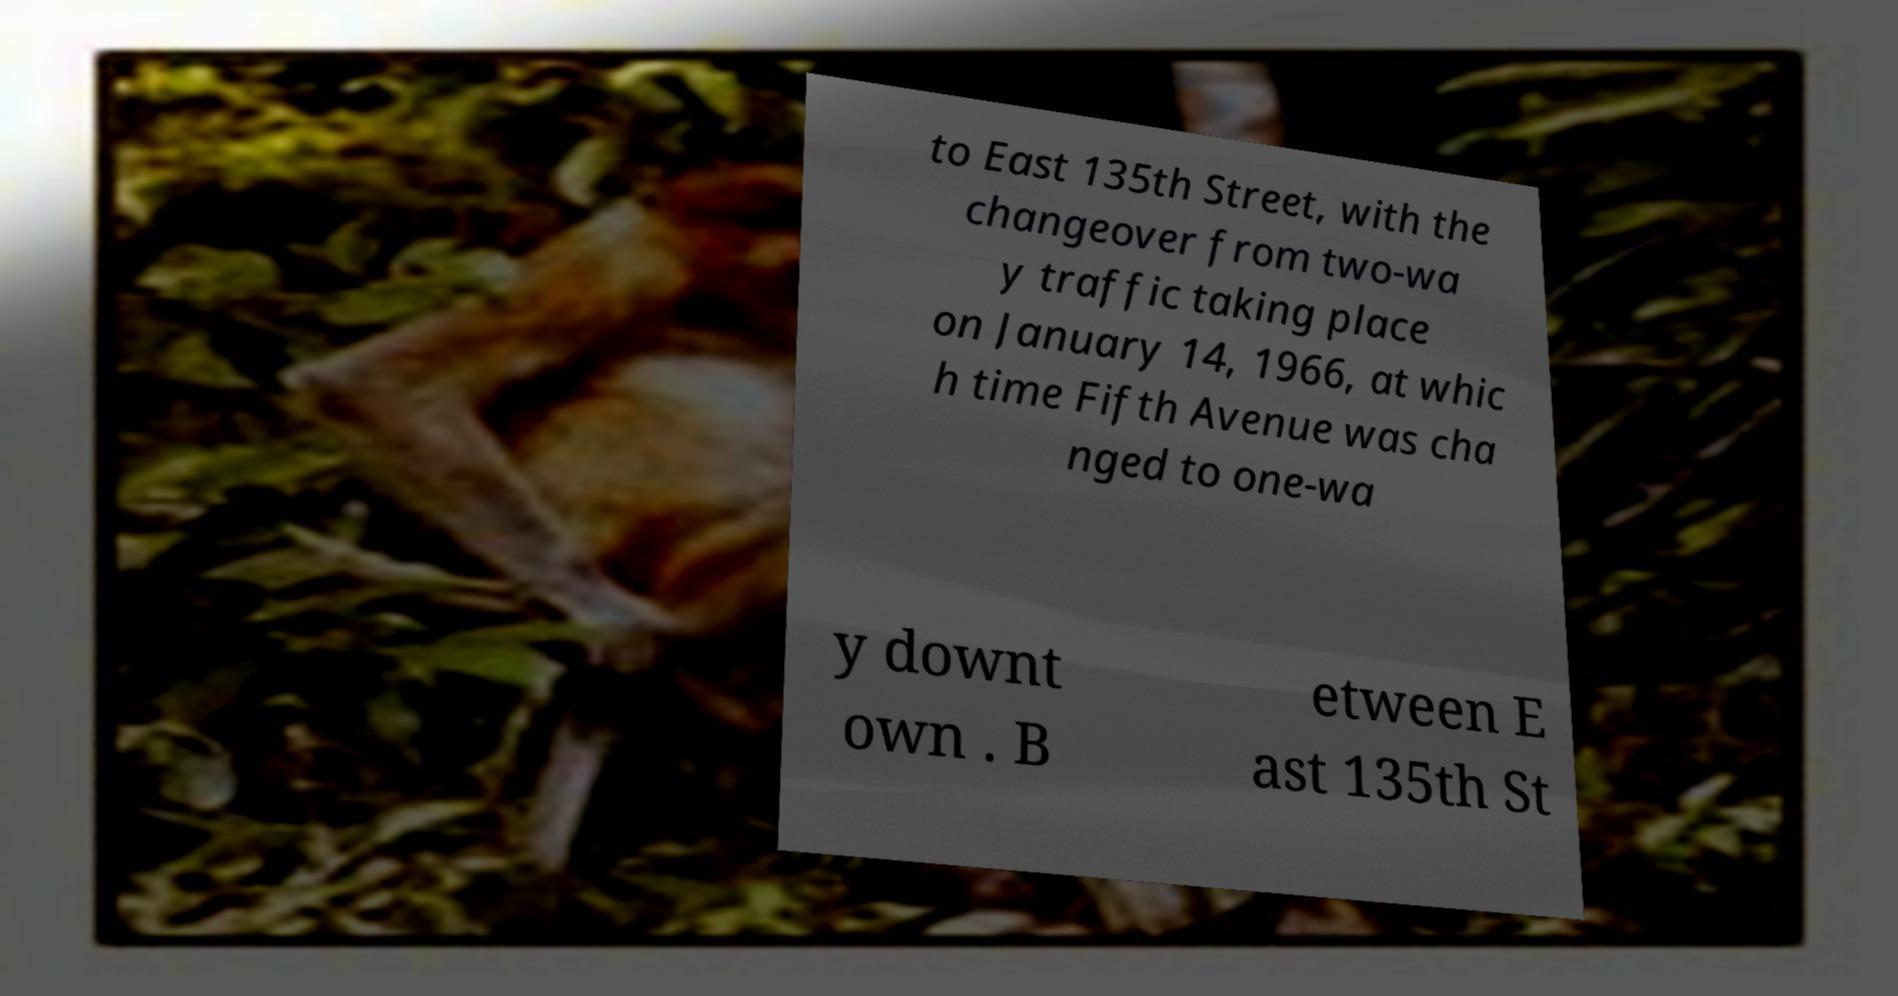For documentation purposes, I need the text within this image transcribed. Could you provide that? to East 135th Street, with the changeover from two-wa y traffic taking place on January 14, 1966, at whic h time Fifth Avenue was cha nged to one-wa y downt own . B etween E ast 135th St 